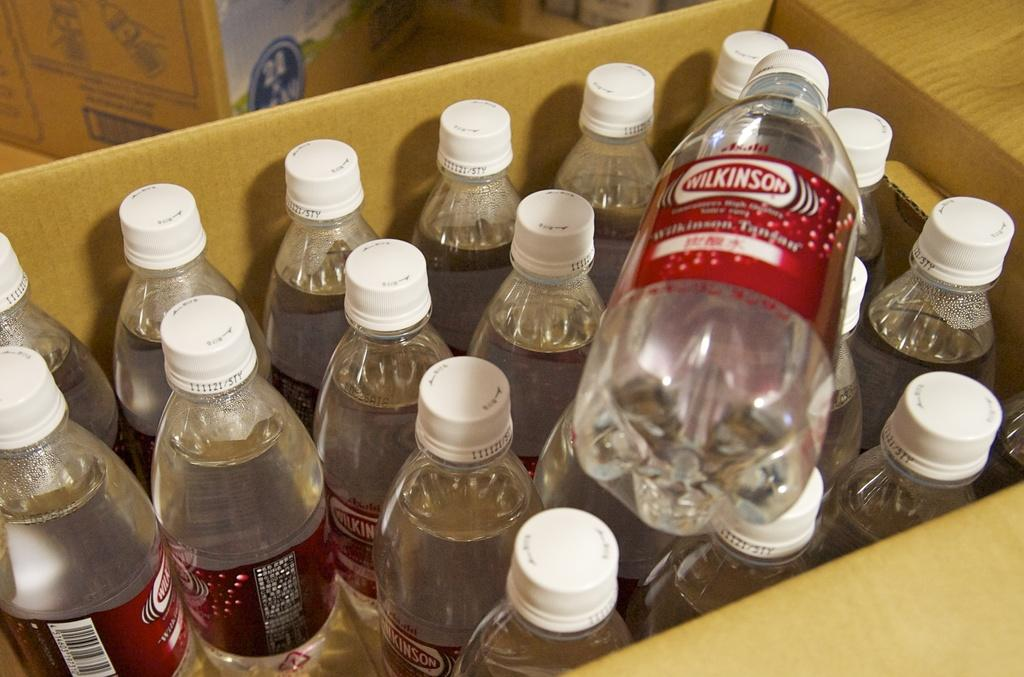What is the main object in the image? There is a box in the image. What is inside the box? The box contains bottles. What can be found on the bottles? The bottles have labels. What information is on the labels? The labels contain text. What type of music is being played by the collar in the image? There is no collar or music present in the image. How does the haircut on the bottle affect the taste of the liquid inside? There is no haircut on the bottle, as the labels contain text, not haircuts. 